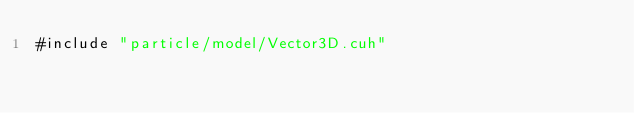<code> <loc_0><loc_0><loc_500><loc_500><_Cuda_>#include "particle/model/Vector3D.cuh"

</code> 